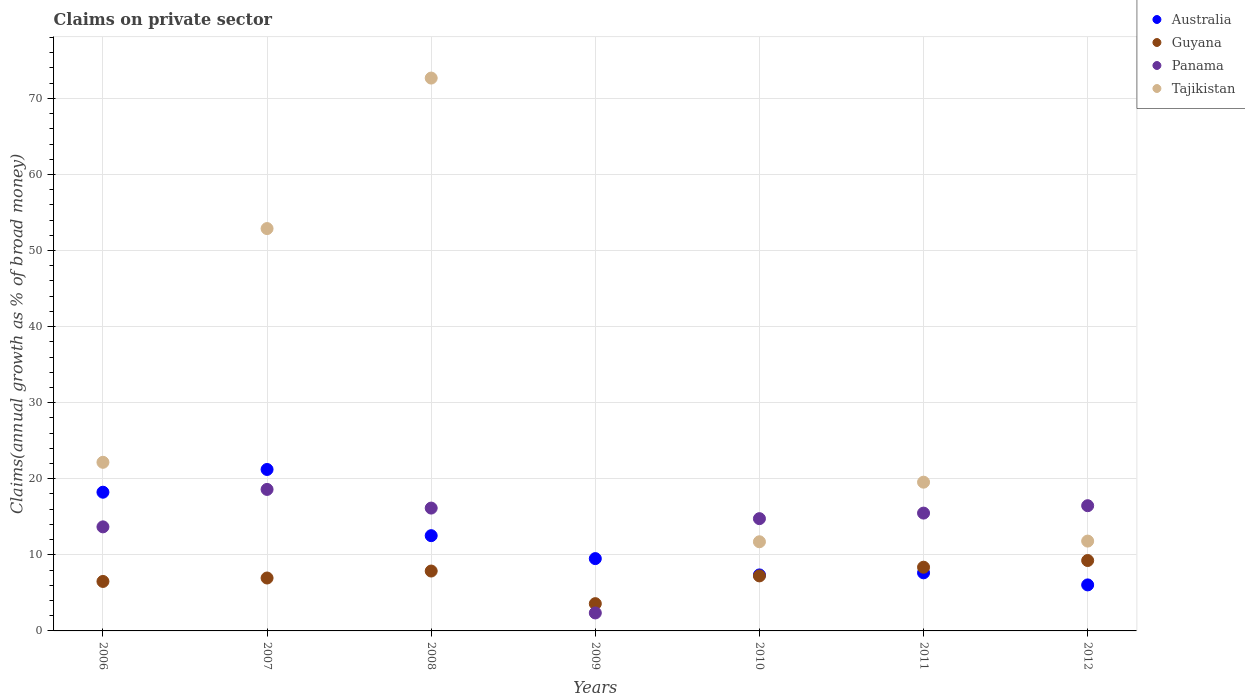How many different coloured dotlines are there?
Provide a short and direct response. 4. What is the percentage of broad money claimed on private sector in Australia in 2007?
Offer a very short reply. 21.22. Across all years, what is the maximum percentage of broad money claimed on private sector in Tajikistan?
Your answer should be very brief. 72.67. Across all years, what is the minimum percentage of broad money claimed on private sector in Panama?
Your answer should be compact. 2.36. In which year was the percentage of broad money claimed on private sector in Tajikistan maximum?
Your answer should be compact. 2008. What is the total percentage of broad money claimed on private sector in Australia in the graph?
Provide a short and direct response. 82.53. What is the difference between the percentage of broad money claimed on private sector in Australia in 2009 and that in 2012?
Keep it short and to the point. 3.46. What is the difference between the percentage of broad money claimed on private sector in Guyana in 2009 and the percentage of broad money claimed on private sector in Tajikistan in 2008?
Make the answer very short. -69.09. What is the average percentage of broad money claimed on private sector in Guyana per year?
Your response must be concise. 7.11. In the year 2006, what is the difference between the percentage of broad money claimed on private sector in Guyana and percentage of broad money claimed on private sector in Panama?
Make the answer very short. -7.17. What is the ratio of the percentage of broad money claimed on private sector in Guyana in 2006 to that in 2012?
Your answer should be very brief. 0.7. Is the percentage of broad money claimed on private sector in Panama in 2007 less than that in 2010?
Offer a very short reply. No. What is the difference between the highest and the second highest percentage of broad money claimed on private sector in Guyana?
Your answer should be very brief. 0.88. What is the difference between the highest and the lowest percentage of broad money claimed on private sector in Tajikistan?
Your response must be concise. 72.67. Is the sum of the percentage of broad money claimed on private sector in Australia in 2008 and 2011 greater than the maximum percentage of broad money claimed on private sector in Guyana across all years?
Make the answer very short. Yes. Is it the case that in every year, the sum of the percentage of broad money claimed on private sector in Panama and percentage of broad money claimed on private sector in Australia  is greater than the percentage of broad money claimed on private sector in Tajikistan?
Keep it short and to the point. No. Is the percentage of broad money claimed on private sector in Guyana strictly greater than the percentage of broad money claimed on private sector in Panama over the years?
Your answer should be compact. No. How many dotlines are there?
Your answer should be very brief. 4. How many years are there in the graph?
Provide a short and direct response. 7. What is the difference between two consecutive major ticks on the Y-axis?
Your response must be concise. 10. Are the values on the major ticks of Y-axis written in scientific E-notation?
Give a very brief answer. No. Does the graph contain any zero values?
Provide a short and direct response. Yes. Does the graph contain grids?
Provide a short and direct response. Yes. How are the legend labels stacked?
Provide a short and direct response. Vertical. What is the title of the graph?
Ensure brevity in your answer.  Claims on private sector. Does "American Samoa" appear as one of the legend labels in the graph?
Your answer should be very brief. No. What is the label or title of the Y-axis?
Offer a very short reply. Claims(annual growth as % of broad money). What is the Claims(annual growth as % of broad money) in Australia in 2006?
Make the answer very short. 18.23. What is the Claims(annual growth as % of broad money) in Guyana in 2006?
Your answer should be very brief. 6.5. What is the Claims(annual growth as % of broad money) of Panama in 2006?
Provide a succinct answer. 13.68. What is the Claims(annual growth as % of broad money) in Tajikistan in 2006?
Give a very brief answer. 22.17. What is the Claims(annual growth as % of broad money) in Australia in 2007?
Make the answer very short. 21.22. What is the Claims(annual growth as % of broad money) of Guyana in 2007?
Provide a short and direct response. 6.96. What is the Claims(annual growth as % of broad money) of Panama in 2007?
Make the answer very short. 18.6. What is the Claims(annual growth as % of broad money) of Tajikistan in 2007?
Your answer should be compact. 52.89. What is the Claims(annual growth as % of broad money) in Australia in 2008?
Your answer should be very brief. 12.52. What is the Claims(annual growth as % of broad money) of Guyana in 2008?
Your response must be concise. 7.87. What is the Claims(annual growth as % of broad money) of Panama in 2008?
Your answer should be compact. 16.15. What is the Claims(annual growth as % of broad money) of Tajikistan in 2008?
Your answer should be very brief. 72.67. What is the Claims(annual growth as % of broad money) of Australia in 2009?
Provide a succinct answer. 9.51. What is the Claims(annual growth as % of broad money) in Guyana in 2009?
Give a very brief answer. 3.58. What is the Claims(annual growth as % of broad money) of Panama in 2009?
Offer a terse response. 2.36. What is the Claims(annual growth as % of broad money) in Tajikistan in 2009?
Your answer should be compact. 0. What is the Claims(annual growth as % of broad money) of Australia in 2010?
Your response must be concise. 7.36. What is the Claims(annual growth as % of broad money) of Guyana in 2010?
Give a very brief answer. 7.23. What is the Claims(annual growth as % of broad money) of Panama in 2010?
Your response must be concise. 14.76. What is the Claims(annual growth as % of broad money) in Tajikistan in 2010?
Your answer should be very brief. 11.72. What is the Claims(annual growth as % of broad money) in Australia in 2011?
Your response must be concise. 7.64. What is the Claims(annual growth as % of broad money) in Guyana in 2011?
Provide a succinct answer. 8.37. What is the Claims(annual growth as % of broad money) of Panama in 2011?
Keep it short and to the point. 15.49. What is the Claims(annual growth as % of broad money) of Tajikistan in 2011?
Your response must be concise. 19.55. What is the Claims(annual growth as % of broad money) of Australia in 2012?
Your response must be concise. 6.05. What is the Claims(annual growth as % of broad money) in Guyana in 2012?
Give a very brief answer. 9.25. What is the Claims(annual growth as % of broad money) in Panama in 2012?
Your answer should be very brief. 16.46. What is the Claims(annual growth as % of broad money) in Tajikistan in 2012?
Offer a very short reply. 11.81. Across all years, what is the maximum Claims(annual growth as % of broad money) in Australia?
Provide a succinct answer. 21.22. Across all years, what is the maximum Claims(annual growth as % of broad money) of Guyana?
Offer a very short reply. 9.25. Across all years, what is the maximum Claims(annual growth as % of broad money) in Panama?
Provide a succinct answer. 18.6. Across all years, what is the maximum Claims(annual growth as % of broad money) of Tajikistan?
Your answer should be very brief. 72.67. Across all years, what is the minimum Claims(annual growth as % of broad money) in Australia?
Your answer should be very brief. 6.05. Across all years, what is the minimum Claims(annual growth as % of broad money) of Guyana?
Give a very brief answer. 3.58. Across all years, what is the minimum Claims(annual growth as % of broad money) in Panama?
Your response must be concise. 2.36. Across all years, what is the minimum Claims(annual growth as % of broad money) in Tajikistan?
Your answer should be compact. 0. What is the total Claims(annual growth as % of broad money) of Australia in the graph?
Offer a very short reply. 82.53. What is the total Claims(annual growth as % of broad money) in Guyana in the graph?
Offer a very short reply. 49.78. What is the total Claims(annual growth as % of broad money) in Panama in the graph?
Your answer should be very brief. 97.5. What is the total Claims(annual growth as % of broad money) of Tajikistan in the graph?
Ensure brevity in your answer.  190.81. What is the difference between the Claims(annual growth as % of broad money) in Australia in 2006 and that in 2007?
Make the answer very short. -2.99. What is the difference between the Claims(annual growth as % of broad money) of Guyana in 2006 and that in 2007?
Offer a very short reply. -0.45. What is the difference between the Claims(annual growth as % of broad money) in Panama in 2006 and that in 2007?
Make the answer very short. -4.92. What is the difference between the Claims(annual growth as % of broad money) in Tajikistan in 2006 and that in 2007?
Make the answer very short. -30.73. What is the difference between the Claims(annual growth as % of broad money) of Australia in 2006 and that in 2008?
Your response must be concise. 5.71. What is the difference between the Claims(annual growth as % of broad money) in Guyana in 2006 and that in 2008?
Your response must be concise. -1.37. What is the difference between the Claims(annual growth as % of broad money) in Panama in 2006 and that in 2008?
Give a very brief answer. -2.47. What is the difference between the Claims(annual growth as % of broad money) of Tajikistan in 2006 and that in 2008?
Ensure brevity in your answer.  -50.51. What is the difference between the Claims(annual growth as % of broad money) of Australia in 2006 and that in 2009?
Ensure brevity in your answer.  8.73. What is the difference between the Claims(annual growth as % of broad money) of Guyana in 2006 and that in 2009?
Give a very brief answer. 2.92. What is the difference between the Claims(annual growth as % of broad money) in Panama in 2006 and that in 2009?
Your answer should be very brief. 11.32. What is the difference between the Claims(annual growth as % of broad money) of Australia in 2006 and that in 2010?
Provide a succinct answer. 10.87. What is the difference between the Claims(annual growth as % of broad money) in Guyana in 2006 and that in 2010?
Ensure brevity in your answer.  -0.73. What is the difference between the Claims(annual growth as % of broad money) in Panama in 2006 and that in 2010?
Make the answer very short. -1.08. What is the difference between the Claims(annual growth as % of broad money) in Tajikistan in 2006 and that in 2010?
Offer a terse response. 10.45. What is the difference between the Claims(annual growth as % of broad money) of Australia in 2006 and that in 2011?
Provide a succinct answer. 10.6. What is the difference between the Claims(annual growth as % of broad money) of Guyana in 2006 and that in 2011?
Provide a succinct answer. -1.87. What is the difference between the Claims(annual growth as % of broad money) of Panama in 2006 and that in 2011?
Your answer should be compact. -1.81. What is the difference between the Claims(annual growth as % of broad money) of Tajikistan in 2006 and that in 2011?
Keep it short and to the point. 2.61. What is the difference between the Claims(annual growth as % of broad money) in Australia in 2006 and that in 2012?
Make the answer very short. 12.19. What is the difference between the Claims(annual growth as % of broad money) in Guyana in 2006 and that in 2012?
Ensure brevity in your answer.  -2.75. What is the difference between the Claims(annual growth as % of broad money) of Panama in 2006 and that in 2012?
Offer a very short reply. -2.78. What is the difference between the Claims(annual growth as % of broad money) in Tajikistan in 2006 and that in 2012?
Provide a short and direct response. 10.36. What is the difference between the Claims(annual growth as % of broad money) of Australia in 2007 and that in 2008?
Your answer should be compact. 8.7. What is the difference between the Claims(annual growth as % of broad money) of Guyana in 2007 and that in 2008?
Ensure brevity in your answer.  -0.92. What is the difference between the Claims(annual growth as % of broad money) of Panama in 2007 and that in 2008?
Give a very brief answer. 2.45. What is the difference between the Claims(annual growth as % of broad money) in Tajikistan in 2007 and that in 2008?
Keep it short and to the point. -19.78. What is the difference between the Claims(annual growth as % of broad money) of Australia in 2007 and that in 2009?
Your response must be concise. 11.72. What is the difference between the Claims(annual growth as % of broad money) of Guyana in 2007 and that in 2009?
Offer a very short reply. 3.37. What is the difference between the Claims(annual growth as % of broad money) of Panama in 2007 and that in 2009?
Make the answer very short. 16.24. What is the difference between the Claims(annual growth as % of broad money) of Australia in 2007 and that in 2010?
Your answer should be very brief. 13.86. What is the difference between the Claims(annual growth as % of broad money) in Guyana in 2007 and that in 2010?
Provide a succinct answer. -0.28. What is the difference between the Claims(annual growth as % of broad money) of Panama in 2007 and that in 2010?
Offer a terse response. 3.84. What is the difference between the Claims(annual growth as % of broad money) of Tajikistan in 2007 and that in 2010?
Make the answer very short. 41.17. What is the difference between the Claims(annual growth as % of broad money) of Australia in 2007 and that in 2011?
Offer a terse response. 13.59. What is the difference between the Claims(annual growth as % of broad money) of Guyana in 2007 and that in 2011?
Provide a short and direct response. -1.42. What is the difference between the Claims(annual growth as % of broad money) in Panama in 2007 and that in 2011?
Offer a terse response. 3.11. What is the difference between the Claims(annual growth as % of broad money) in Tajikistan in 2007 and that in 2011?
Offer a terse response. 33.34. What is the difference between the Claims(annual growth as % of broad money) in Australia in 2007 and that in 2012?
Ensure brevity in your answer.  15.17. What is the difference between the Claims(annual growth as % of broad money) of Guyana in 2007 and that in 2012?
Offer a terse response. -2.3. What is the difference between the Claims(annual growth as % of broad money) in Panama in 2007 and that in 2012?
Make the answer very short. 2.14. What is the difference between the Claims(annual growth as % of broad money) in Tajikistan in 2007 and that in 2012?
Provide a succinct answer. 41.08. What is the difference between the Claims(annual growth as % of broad money) in Australia in 2008 and that in 2009?
Make the answer very short. 3.01. What is the difference between the Claims(annual growth as % of broad money) in Guyana in 2008 and that in 2009?
Provide a short and direct response. 4.29. What is the difference between the Claims(annual growth as % of broad money) of Panama in 2008 and that in 2009?
Offer a very short reply. 13.78. What is the difference between the Claims(annual growth as % of broad money) of Australia in 2008 and that in 2010?
Provide a succinct answer. 5.16. What is the difference between the Claims(annual growth as % of broad money) of Guyana in 2008 and that in 2010?
Keep it short and to the point. 0.64. What is the difference between the Claims(annual growth as % of broad money) of Panama in 2008 and that in 2010?
Give a very brief answer. 1.39. What is the difference between the Claims(annual growth as % of broad money) of Tajikistan in 2008 and that in 2010?
Offer a terse response. 60.95. What is the difference between the Claims(annual growth as % of broad money) in Australia in 2008 and that in 2011?
Keep it short and to the point. 4.88. What is the difference between the Claims(annual growth as % of broad money) of Guyana in 2008 and that in 2011?
Provide a short and direct response. -0.5. What is the difference between the Claims(annual growth as % of broad money) in Panama in 2008 and that in 2011?
Your answer should be very brief. 0.66. What is the difference between the Claims(annual growth as % of broad money) of Tajikistan in 2008 and that in 2011?
Offer a very short reply. 53.12. What is the difference between the Claims(annual growth as % of broad money) of Australia in 2008 and that in 2012?
Give a very brief answer. 6.47. What is the difference between the Claims(annual growth as % of broad money) of Guyana in 2008 and that in 2012?
Keep it short and to the point. -1.38. What is the difference between the Claims(annual growth as % of broad money) of Panama in 2008 and that in 2012?
Make the answer very short. -0.31. What is the difference between the Claims(annual growth as % of broad money) in Tajikistan in 2008 and that in 2012?
Make the answer very short. 60.86. What is the difference between the Claims(annual growth as % of broad money) of Australia in 2009 and that in 2010?
Ensure brevity in your answer.  2.14. What is the difference between the Claims(annual growth as % of broad money) in Guyana in 2009 and that in 2010?
Your answer should be compact. -3.65. What is the difference between the Claims(annual growth as % of broad money) in Panama in 2009 and that in 2010?
Make the answer very short. -12.39. What is the difference between the Claims(annual growth as % of broad money) of Australia in 2009 and that in 2011?
Your answer should be very brief. 1.87. What is the difference between the Claims(annual growth as % of broad money) of Guyana in 2009 and that in 2011?
Your answer should be compact. -4.79. What is the difference between the Claims(annual growth as % of broad money) of Panama in 2009 and that in 2011?
Provide a succinct answer. -13.13. What is the difference between the Claims(annual growth as % of broad money) in Australia in 2009 and that in 2012?
Provide a short and direct response. 3.46. What is the difference between the Claims(annual growth as % of broad money) in Guyana in 2009 and that in 2012?
Keep it short and to the point. -5.67. What is the difference between the Claims(annual growth as % of broad money) in Panama in 2009 and that in 2012?
Offer a terse response. -14.1. What is the difference between the Claims(annual growth as % of broad money) in Australia in 2010 and that in 2011?
Your response must be concise. -0.27. What is the difference between the Claims(annual growth as % of broad money) in Guyana in 2010 and that in 2011?
Your response must be concise. -1.14. What is the difference between the Claims(annual growth as % of broad money) of Panama in 2010 and that in 2011?
Offer a very short reply. -0.73. What is the difference between the Claims(annual growth as % of broad money) of Tajikistan in 2010 and that in 2011?
Give a very brief answer. -7.83. What is the difference between the Claims(annual growth as % of broad money) in Australia in 2010 and that in 2012?
Keep it short and to the point. 1.31. What is the difference between the Claims(annual growth as % of broad money) of Guyana in 2010 and that in 2012?
Ensure brevity in your answer.  -2.02. What is the difference between the Claims(annual growth as % of broad money) in Panama in 2010 and that in 2012?
Ensure brevity in your answer.  -1.7. What is the difference between the Claims(annual growth as % of broad money) in Tajikistan in 2010 and that in 2012?
Ensure brevity in your answer.  -0.09. What is the difference between the Claims(annual growth as % of broad money) of Australia in 2011 and that in 2012?
Ensure brevity in your answer.  1.59. What is the difference between the Claims(annual growth as % of broad money) of Guyana in 2011 and that in 2012?
Ensure brevity in your answer.  -0.88. What is the difference between the Claims(annual growth as % of broad money) in Panama in 2011 and that in 2012?
Offer a terse response. -0.97. What is the difference between the Claims(annual growth as % of broad money) in Tajikistan in 2011 and that in 2012?
Your response must be concise. 7.74. What is the difference between the Claims(annual growth as % of broad money) in Australia in 2006 and the Claims(annual growth as % of broad money) in Guyana in 2007?
Offer a terse response. 11.28. What is the difference between the Claims(annual growth as % of broad money) of Australia in 2006 and the Claims(annual growth as % of broad money) of Panama in 2007?
Ensure brevity in your answer.  -0.37. What is the difference between the Claims(annual growth as % of broad money) of Australia in 2006 and the Claims(annual growth as % of broad money) of Tajikistan in 2007?
Ensure brevity in your answer.  -34.66. What is the difference between the Claims(annual growth as % of broad money) of Guyana in 2006 and the Claims(annual growth as % of broad money) of Panama in 2007?
Your answer should be very brief. -12.1. What is the difference between the Claims(annual growth as % of broad money) of Guyana in 2006 and the Claims(annual growth as % of broad money) of Tajikistan in 2007?
Your response must be concise. -46.39. What is the difference between the Claims(annual growth as % of broad money) in Panama in 2006 and the Claims(annual growth as % of broad money) in Tajikistan in 2007?
Make the answer very short. -39.21. What is the difference between the Claims(annual growth as % of broad money) of Australia in 2006 and the Claims(annual growth as % of broad money) of Guyana in 2008?
Keep it short and to the point. 10.36. What is the difference between the Claims(annual growth as % of broad money) in Australia in 2006 and the Claims(annual growth as % of broad money) in Panama in 2008?
Your response must be concise. 2.09. What is the difference between the Claims(annual growth as % of broad money) in Australia in 2006 and the Claims(annual growth as % of broad money) in Tajikistan in 2008?
Give a very brief answer. -54.44. What is the difference between the Claims(annual growth as % of broad money) of Guyana in 2006 and the Claims(annual growth as % of broad money) of Panama in 2008?
Provide a succinct answer. -9.64. What is the difference between the Claims(annual growth as % of broad money) of Guyana in 2006 and the Claims(annual growth as % of broad money) of Tajikistan in 2008?
Your response must be concise. -66.17. What is the difference between the Claims(annual growth as % of broad money) in Panama in 2006 and the Claims(annual growth as % of broad money) in Tajikistan in 2008?
Keep it short and to the point. -58.99. What is the difference between the Claims(annual growth as % of broad money) of Australia in 2006 and the Claims(annual growth as % of broad money) of Guyana in 2009?
Offer a terse response. 14.65. What is the difference between the Claims(annual growth as % of broad money) in Australia in 2006 and the Claims(annual growth as % of broad money) in Panama in 2009?
Your response must be concise. 15.87. What is the difference between the Claims(annual growth as % of broad money) of Guyana in 2006 and the Claims(annual growth as % of broad money) of Panama in 2009?
Give a very brief answer. 4.14. What is the difference between the Claims(annual growth as % of broad money) in Australia in 2006 and the Claims(annual growth as % of broad money) in Guyana in 2010?
Ensure brevity in your answer.  11. What is the difference between the Claims(annual growth as % of broad money) in Australia in 2006 and the Claims(annual growth as % of broad money) in Panama in 2010?
Give a very brief answer. 3.48. What is the difference between the Claims(annual growth as % of broad money) of Australia in 2006 and the Claims(annual growth as % of broad money) of Tajikistan in 2010?
Offer a terse response. 6.51. What is the difference between the Claims(annual growth as % of broad money) of Guyana in 2006 and the Claims(annual growth as % of broad money) of Panama in 2010?
Make the answer very short. -8.25. What is the difference between the Claims(annual growth as % of broad money) in Guyana in 2006 and the Claims(annual growth as % of broad money) in Tajikistan in 2010?
Offer a very short reply. -5.22. What is the difference between the Claims(annual growth as % of broad money) of Panama in 2006 and the Claims(annual growth as % of broad money) of Tajikistan in 2010?
Offer a terse response. 1.96. What is the difference between the Claims(annual growth as % of broad money) in Australia in 2006 and the Claims(annual growth as % of broad money) in Guyana in 2011?
Provide a short and direct response. 9.86. What is the difference between the Claims(annual growth as % of broad money) of Australia in 2006 and the Claims(annual growth as % of broad money) of Panama in 2011?
Provide a succinct answer. 2.75. What is the difference between the Claims(annual growth as % of broad money) of Australia in 2006 and the Claims(annual growth as % of broad money) of Tajikistan in 2011?
Provide a succinct answer. -1.32. What is the difference between the Claims(annual growth as % of broad money) of Guyana in 2006 and the Claims(annual growth as % of broad money) of Panama in 2011?
Provide a short and direct response. -8.98. What is the difference between the Claims(annual growth as % of broad money) of Guyana in 2006 and the Claims(annual growth as % of broad money) of Tajikistan in 2011?
Your answer should be compact. -13.05. What is the difference between the Claims(annual growth as % of broad money) of Panama in 2006 and the Claims(annual growth as % of broad money) of Tajikistan in 2011?
Offer a very short reply. -5.87. What is the difference between the Claims(annual growth as % of broad money) in Australia in 2006 and the Claims(annual growth as % of broad money) in Guyana in 2012?
Make the answer very short. 8.98. What is the difference between the Claims(annual growth as % of broad money) in Australia in 2006 and the Claims(annual growth as % of broad money) in Panama in 2012?
Provide a short and direct response. 1.77. What is the difference between the Claims(annual growth as % of broad money) of Australia in 2006 and the Claims(annual growth as % of broad money) of Tajikistan in 2012?
Your answer should be compact. 6.42. What is the difference between the Claims(annual growth as % of broad money) in Guyana in 2006 and the Claims(annual growth as % of broad money) in Panama in 2012?
Ensure brevity in your answer.  -9.96. What is the difference between the Claims(annual growth as % of broad money) in Guyana in 2006 and the Claims(annual growth as % of broad money) in Tajikistan in 2012?
Make the answer very short. -5.31. What is the difference between the Claims(annual growth as % of broad money) in Panama in 2006 and the Claims(annual growth as % of broad money) in Tajikistan in 2012?
Offer a very short reply. 1.87. What is the difference between the Claims(annual growth as % of broad money) of Australia in 2007 and the Claims(annual growth as % of broad money) of Guyana in 2008?
Your answer should be very brief. 13.35. What is the difference between the Claims(annual growth as % of broad money) in Australia in 2007 and the Claims(annual growth as % of broad money) in Panama in 2008?
Your answer should be very brief. 5.08. What is the difference between the Claims(annual growth as % of broad money) of Australia in 2007 and the Claims(annual growth as % of broad money) of Tajikistan in 2008?
Your answer should be very brief. -51.45. What is the difference between the Claims(annual growth as % of broad money) of Guyana in 2007 and the Claims(annual growth as % of broad money) of Panama in 2008?
Make the answer very short. -9.19. What is the difference between the Claims(annual growth as % of broad money) in Guyana in 2007 and the Claims(annual growth as % of broad money) in Tajikistan in 2008?
Keep it short and to the point. -65.72. What is the difference between the Claims(annual growth as % of broad money) in Panama in 2007 and the Claims(annual growth as % of broad money) in Tajikistan in 2008?
Offer a terse response. -54.07. What is the difference between the Claims(annual growth as % of broad money) in Australia in 2007 and the Claims(annual growth as % of broad money) in Guyana in 2009?
Your response must be concise. 17.64. What is the difference between the Claims(annual growth as % of broad money) in Australia in 2007 and the Claims(annual growth as % of broad money) in Panama in 2009?
Offer a terse response. 18.86. What is the difference between the Claims(annual growth as % of broad money) of Guyana in 2007 and the Claims(annual growth as % of broad money) of Panama in 2009?
Offer a terse response. 4.59. What is the difference between the Claims(annual growth as % of broad money) in Australia in 2007 and the Claims(annual growth as % of broad money) in Guyana in 2010?
Provide a short and direct response. 13.99. What is the difference between the Claims(annual growth as % of broad money) of Australia in 2007 and the Claims(annual growth as % of broad money) of Panama in 2010?
Your response must be concise. 6.47. What is the difference between the Claims(annual growth as % of broad money) in Australia in 2007 and the Claims(annual growth as % of broad money) in Tajikistan in 2010?
Make the answer very short. 9.5. What is the difference between the Claims(annual growth as % of broad money) of Guyana in 2007 and the Claims(annual growth as % of broad money) of Panama in 2010?
Provide a short and direct response. -7.8. What is the difference between the Claims(annual growth as % of broad money) in Guyana in 2007 and the Claims(annual growth as % of broad money) in Tajikistan in 2010?
Make the answer very short. -4.76. What is the difference between the Claims(annual growth as % of broad money) of Panama in 2007 and the Claims(annual growth as % of broad money) of Tajikistan in 2010?
Provide a short and direct response. 6.88. What is the difference between the Claims(annual growth as % of broad money) in Australia in 2007 and the Claims(annual growth as % of broad money) in Guyana in 2011?
Offer a terse response. 12.85. What is the difference between the Claims(annual growth as % of broad money) of Australia in 2007 and the Claims(annual growth as % of broad money) of Panama in 2011?
Provide a short and direct response. 5.73. What is the difference between the Claims(annual growth as % of broad money) of Australia in 2007 and the Claims(annual growth as % of broad money) of Tajikistan in 2011?
Make the answer very short. 1.67. What is the difference between the Claims(annual growth as % of broad money) in Guyana in 2007 and the Claims(annual growth as % of broad money) in Panama in 2011?
Your answer should be compact. -8.53. What is the difference between the Claims(annual growth as % of broad money) of Guyana in 2007 and the Claims(annual growth as % of broad money) of Tajikistan in 2011?
Give a very brief answer. -12.6. What is the difference between the Claims(annual growth as % of broad money) of Panama in 2007 and the Claims(annual growth as % of broad money) of Tajikistan in 2011?
Offer a very short reply. -0.95. What is the difference between the Claims(annual growth as % of broad money) of Australia in 2007 and the Claims(annual growth as % of broad money) of Guyana in 2012?
Offer a very short reply. 11.97. What is the difference between the Claims(annual growth as % of broad money) in Australia in 2007 and the Claims(annual growth as % of broad money) in Panama in 2012?
Your answer should be very brief. 4.76. What is the difference between the Claims(annual growth as % of broad money) in Australia in 2007 and the Claims(annual growth as % of broad money) in Tajikistan in 2012?
Keep it short and to the point. 9.41. What is the difference between the Claims(annual growth as % of broad money) in Guyana in 2007 and the Claims(annual growth as % of broad money) in Panama in 2012?
Keep it short and to the point. -9.51. What is the difference between the Claims(annual growth as % of broad money) of Guyana in 2007 and the Claims(annual growth as % of broad money) of Tajikistan in 2012?
Offer a terse response. -4.85. What is the difference between the Claims(annual growth as % of broad money) in Panama in 2007 and the Claims(annual growth as % of broad money) in Tajikistan in 2012?
Give a very brief answer. 6.79. What is the difference between the Claims(annual growth as % of broad money) of Australia in 2008 and the Claims(annual growth as % of broad money) of Guyana in 2009?
Your response must be concise. 8.94. What is the difference between the Claims(annual growth as % of broad money) of Australia in 2008 and the Claims(annual growth as % of broad money) of Panama in 2009?
Provide a succinct answer. 10.16. What is the difference between the Claims(annual growth as % of broad money) in Guyana in 2008 and the Claims(annual growth as % of broad money) in Panama in 2009?
Keep it short and to the point. 5.51. What is the difference between the Claims(annual growth as % of broad money) in Australia in 2008 and the Claims(annual growth as % of broad money) in Guyana in 2010?
Your answer should be compact. 5.29. What is the difference between the Claims(annual growth as % of broad money) of Australia in 2008 and the Claims(annual growth as % of broad money) of Panama in 2010?
Make the answer very short. -2.24. What is the difference between the Claims(annual growth as % of broad money) of Australia in 2008 and the Claims(annual growth as % of broad money) of Tajikistan in 2010?
Ensure brevity in your answer.  0.8. What is the difference between the Claims(annual growth as % of broad money) of Guyana in 2008 and the Claims(annual growth as % of broad money) of Panama in 2010?
Make the answer very short. -6.89. What is the difference between the Claims(annual growth as % of broad money) in Guyana in 2008 and the Claims(annual growth as % of broad money) in Tajikistan in 2010?
Give a very brief answer. -3.85. What is the difference between the Claims(annual growth as % of broad money) of Panama in 2008 and the Claims(annual growth as % of broad money) of Tajikistan in 2010?
Ensure brevity in your answer.  4.43. What is the difference between the Claims(annual growth as % of broad money) of Australia in 2008 and the Claims(annual growth as % of broad money) of Guyana in 2011?
Make the answer very short. 4.15. What is the difference between the Claims(annual growth as % of broad money) of Australia in 2008 and the Claims(annual growth as % of broad money) of Panama in 2011?
Offer a terse response. -2.97. What is the difference between the Claims(annual growth as % of broad money) in Australia in 2008 and the Claims(annual growth as % of broad money) in Tajikistan in 2011?
Your answer should be very brief. -7.03. What is the difference between the Claims(annual growth as % of broad money) of Guyana in 2008 and the Claims(annual growth as % of broad money) of Panama in 2011?
Keep it short and to the point. -7.62. What is the difference between the Claims(annual growth as % of broad money) of Guyana in 2008 and the Claims(annual growth as % of broad money) of Tajikistan in 2011?
Provide a short and direct response. -11.68. What is the difference between the Claims(annual growth as % of broad money) in Panama in 2008 and the Claims(annual growth as % of broad money) in Tajikistan in 2011?
Make the answer very short. -3.41. What is the difference between the Claims(annual growth as % of broad money) in Australia in 2008 and the Claims(annual growth as % of broad money) in Guyana in 2012?
Your response must be concise. 3.27. What is the difference between the Claims(annual growth as % of broad money) of Australia in 2008 and the Claims(annual growth as % of broad money) of Panama in 2012?
Your answer should be compact. -3.94. What is the difference between the Claims(annual growth as % of broad money) in Australia in 2008 and the Claims(annual growth as % of broad money) in Tajikistan in 2012?
Make the answer very short. 0.71. What is the difference between the Claims(annual growth as % of broad money) of Guyana in 2008 and the Claims(annual growth as % of broad money) of Panama in 2012?
Ensure brevity in your answer.  -8.59. What is the difference between the Claims(annual growth as % of broad money) in Guyana in 2008 and the Claims(annual growth as % of broad money) in Tajikistan in 2012?
Make the answer very short. -3.94. What is the difference between the Claims(annual growth as % of broad money) in Panama in 2008 and the Claims(annual growth as % of broad money) in Tajikistan in 2012?
Your answer should be compact. 4.34. What is the difference between the Claims(annual growth as % of broad money) of Australia in 2009 and the Claims(annual growth as % of broad money) of Guyana in 2010?
Give a very brief answer. 2.27. What is the difference between the Claims(annual growth as % of broad money) of Australia in 2009 and the Claims(annual growth as % of broad money) of Panama in 2010?
Keep it short and to the point. -5.25. What is the difference between the Claims(annual growth as % of broad money) of Australia in 2009 and the Claims(annual growth as % of broad money) of Tajikistan in 2010?
Your response must be concise. -2.21. What is the difference between the Claims(annual growth as % of broad money) in Guyana in 2009 and the Claims(annual growth as % of broad money) in Panama in 2010?
Offer a very short reply. -11.17. What is the difference between the Claims(annual growth as % of broad money) in Guyana in 2009 and the Claims(annual growth as % of broad money) in Tajikistan in 2010?
Keep it short and to the point. -8.14. What is the difference between the Claims(annual growth as % of broad money) of Panama in 2009 and the Claims(annual growth as % of broad money) of Tajikistan in 2010?
Ensure brevity in your answer.  -9.36. What is the difference between the Claims(annual growth as % of broad money) in Australia in 2009 and the Claims(annual growth as % of broad money) in Guyana in 2011?
Keep it short and to the point. 1.13. What is the difference between the Claims(annual growth as % of broad money) of Australia in 2009 and the Claims(annual growth as % of broad money) of Panama in 2011?
Ensure brevity in your answer.  -5.98. What is the difference between the Claims(annual growth as % of broad money) of Australia in 2009 and the Claims(annual growth as % of broad money) of Tajikistan in 2011?
Give a very brief answer. -10.05. What is the difference between the Claims(annual growth as % of broad money) of Guyana in 2009 and the Claims(annual growth as % of broad money) of Panama in 2011?
Your response must be concise. -11.9. What is the difference between the Claims(annual growth as % of broad money) of Guyana in 2009 and the Claims(annual growth as % of broad money) of Tajikistan in 2011?
Your response must be concise. -15.97. What is the difference between the Claims(annual growth as % of broad money) in Panama in 2009 and the Claims(annual growth as % of broad money) in Tajikistan in 2011?
Your answer should be compact. -17.19. What is the difference between the Claims(annual growth as % of broad money) in Australia in 2009 and the Claims(annual growth as % of broad money) in Guyana in 2012?
Provide a short and direct response. 0.25. What is the difference between the Claims(annual growth as % of broad money) in Australia in 2009 and the Claims(annual growth as % of broad money) in Panama in 2012?
Ensure brevity in your answer.  -6.95. What is the difference between the Claims(annual growth as % of broad money) in Australia in 2009 and the Claims(annual growth as % of broad money) in Tajikistan in 2012?
Ensure brevity in your answer.  -2.3. What is the difference between the Claims(annual growth as % of broad money) of Guyana in 2009 and the Claims(annual growth as % of broad money) of Panama in 2012?
Make the answer very short. -12.88. What is the difference between the Claims(annual growth as % of broad money) of Guyana in 2009 and the Claims(annual growth as % of broad money) of Tajikistan in 2012?
Ensure brevity in your answer.  -8.23. What is the difference between the Claims(annual growth as % of broad money) of Panama in 2009 and the Claims(annual growth as % of broad money) of Tajikistan in 2012?
Offer a terse response. -9.45. What is the difference between the Claims(annual growth as % of broad money) in Australia in 2010 and the Claims(annual growth as % of broad money) in Guyana in 2011?
Ensure brevity in your answer.  -1.01. What is the difference between the Claims(annual growth as % of broad money) in Australia in 2010 and the Claims(annual growth as % of broad money) in Panama in 2011?
Your answer should be compact. -8.13. What is the difference between the Claims(annual growth as % of broad money) of Australia in 2010 and the Claims(annual growth as % of broad money) of Tajikistan in 2011?
Provide a succinct answer. -12.19. What is the difference between the Claims(annual growth as % of broad money) in Guyana in 2010 and the Claims(annual growth as % of broad money) in Panama in 2011?
Ensure brevity in your answer.  -8.26. What is the difference between the Claims(annual growth as % of broad money) in Guyana in 2010 and the Claims(annual growth as % of broad money) in Tajikistan in 2011?
Provide a succinct answer. -12.32. What is the difference between the Claims(annual growth as % of broad money) in Panama in 2010 and the Claims(annual growth as % of broad money) in Tajikistan in 2011?
Your answer should be very brief. -4.8. What is the difference between the Claims(annual growth as % of broad money) of Australia in 2010 and the Claims(annual growth as % of broad money) of Guyana in 2012?
Your answer should be very brief. -1.89. What is the difference between the Claims(annual growth as % of broad money) in Australia in 2010 and the Claims(annual growth as % of broad money) in Panama in 2012?
Give a very brief answer. -9.1. What is the difference between the Claims(annual growth as % of broad money) of Australia in 2010 and the Claims(annual growth as % of broad money) of Tajikistan in 2012?
Give a very brief answer. -4.45. What is the difference between the Claims(annual growth as % of broad money) of Guyana in 2010 and the Claims(annual growth as % of broad money) of Panama in 2012?
Ensure brevity in your answer.  -9.23. What is the difference between the Claims(annual growth as % of broad money) of Guyana in 2010 and the Claims(annual growth as % of broad money) of Tajikistan in 2012?
Make the answer very short. -4.58. What is the difference between the Claims(annual growth as % of broad money) in Panama in 2010 and the Claims(annual growth as % of broad money) in Tajikistan in 2012?
Provide a succinct answer. 2.95. What is the difference between the Claims(annual growth as % of broad money) in Australia in 2011 and the Claims(annual growth as % of broad money) in Guyana in 2012?
Your answer should be compact. -1.62. What is the difference between the Claims(annual growth as % of broad money) in Australia in 2011 and the Claims(annual growth as % of broad money) in Panama in 2012?
Keep it short and to the point. -8.82. What is the difference between the Claims(annual growth as % of broad money) in Australia in 2011 and the Claims(annual growth as % of broad money) in Tajikistan in 2012?
Ensure brevity in your answer.  -4.17. What is the difference between the Claims(annual growth as % of broad money) in Guyana in 2011 and the Claims(annual growth as % of broad money) in Panama in 2012?
Offer a very short reply. -8.09. What is the difference between the Claims(annual growth as % of broad money) of Guyana in 2011 and the Claims(annual growth as % of broad money) of Tajikistan in 2012?
Your answer should be compact. -3.43. What is the difference between the Claims(annual growth as % of broad money) of Panama in 2011 and the Claims(annual growth as % of broad money) of Tajikistan in 2012?
Offer a terse response. 3.68. What is the average Claims(annual growth as % of broad money) of Australia per year?
Keep it short and to the point. 11.79. What is the average Claims(annual growth as % of broad money) of Guyana per year?
Provide a succinct answer. 7.11. What is the average Claims(annual growth as % of broad money) of Panama per year?
Your response must be concise. 13.93. What is the average Claims(annual growth as % of broad money) of Tajikistan per year?
Offer a terse response. 27.26. In the year 2006, what is the difference between the Claims(annual growth as % of broad money) in Australia and Claims(annual growth as % of broad money) in Guyana?
Your answer should be very brief. 11.73. In the year 2006, what is the difference between the Claims(annual growth as % of broad money) of Australia and Claims(annual growth as % of broad money) of Panama?
Your answer should be very brief. 4.56. In the year 2006, what is the difference between the Claims(annual growth as % of broad money) of Australia and Claims(annual growth as % of broad money) of Tajikistan?
Your answer should be compact. -3.93. In the year 2006, what is the difference between the Claims(annual growth as % of broad money) in Guyana and Claims(annual growth as % of broad money) in Panama?
Make the answer very short. -7.17. In the year 2006, what is the difference between the Claims(annual growth as % of broad money) of Guyana and Claims(annual growth as % of broad money) of Tajikistan?
Your answer should be compact. -15.66. In the year 2006, what is the difference between the Claims(annual growth as % of broad money) in Panama and Claims(annual growth as % of broad money) in Tajikistan?
Your response must be concise. -8.49. In the year 2007, what is the difference between the Claims(annual growth as % of broad money) of Australia and Claims(annual growth as % of broad money) of Guyana?
Offer a very short reply. 14.27. In the year 2007, what is the difference between the Claims(annual growth as % of broad money) of Australia and Claims(annual growth as % of broad money) of Panama?
Give a very brief answer. 2.62. In the year 2007, what is the difference between the Claims(annual growth as % of broad money) in Australia and Claims(annual growth as % of broad money) in Tajikistan?
Keep it short and to the point. -31.67. In the year 2007, what is the difference between the Claims(annual growth as % of broad money) of Guyana and Claims(annual growth as % of broad money) of Panama?
Your response must be concise. -11.65. In the year 2007, what is the difference between the Claims(annual growth as % of broad money) of Guyana and Claims(annual growth as % of broad money) of Tajikistan?
Your response must be concise. -45.94. In the year 2007, what is the difference between the Claims(annual growth as % of broad money) of Panama and Claims(annual growth as % of broad money) of Tajikistan?
Provide a succinct answer. -34.29. In the year 2008, what is the difference between the Claims(annual growth as % of broad money) in Australia and Claims(annual growth as % of broad money) in Guyana?
Make the answer very short. 4.65. In the year 2008, what is the difference between the Claims(annual growth as % of broad money) of Australia and Claims(annual growth as % of broad money) of Panama?
Your answer should be very brief. -3.63. In the year 2008, what is the difference between the Claims(annual growth as % of broad money) in Australia and Claims(annual growth as % of broad money) in Tajikistan?
Provide a succinct answer. -60.15. In the year 2008, what is the difference between the Claims(annual growth as % of broad money) of Guyana and Claims(annual growth as % of broad money) of Panama?
Give a very brief answer. -8.28. In the year 2008, what is the difference between the Claims(annual growth as % of broad money) in Guyana and Claims(annual growth as % of broad money) in Tajikistan?
Provide a short and direct response. -64.8. In the year 2008, what is the difference between the Claims(annual growth as % of broad money) of Panama and Claims(annual growth as % of broad money) of Tajikistan?
Offer a terse response. -56.53. In the year 2009, what is the difference between the Claims(annual growth as % of broad money) in Australia and Claims(annual growth as % of broad money) in Guyana?
Your answer should be compact. 5.92. In the year 2009, what is the difference between the Claims(annual growth as % of broad money) of Australia and Claims(annual growth as % of broad money) of Panama?
Provide a short and direct response. 7.14. In the year 2009, what is the difference between the Claims(annual growth as % of broad money) in Guyana and Claims(annual growth as % of broad money) in Panama?
Make the answer very short. 1.22. In the year 2010, what is the difference between the Claims(annual growth as % of broad money) in Australia and Claims(annual growth as % of broad money) in Guyana?
Offer a very short reply. 0.13. In the year 2010, what is the difference between the Claims(annual growth as % of broad money) of Australia and Claims(annual growth as % of broad money) of Panama?
Keep it short and to the point. -7.39. In the year 2010, what is the difference between the Claims(annual growth as % of broad money) of Australia and Claims(annual growth as % of broad money) of Tajikistan?
Give a very brief answer. -4.36. In the year 2010, what is the difference between the Claims(annual growth as % of broad money) in Guyana and Claims(annual growth as % of broad money) in Panama?
Offer a very short reply. -7.53. In the year 2010, what is the difference between the Claims(annual growth as % of broad money) of Guyana and Claims(annual growth as % of broad money) of Tajikistan?
Give a very brief answer. -4.49. In the year 2010, what is the difference between the Claims(annual growth as % of broad money) in Panama and Claims(annual growth as % of broad money) in Tajikistan?
Offer a very short reply. 3.04. In the year 2011, what is the difference between the Claims(annual growth as % of broad money) in Australia and Claims(annual growth as % of broad money) in Guyana?
Provide a short and direct response. -0.74. In the year 2011, what is the difference between the Claims(annual growth as % of broad money) in Australia and Claims(annual growth as % of broad money) in Panama?
Provide a succinct answer. -7.85. In the year 2011, what is the difference between the Claims(annual growth as % of broad money) of Australia and Claims(annual growth as % of broad money) of Tajikistan?
Your answer should be compact. -11.92. In the year 2011, what is the difference between the Claims(annual growth as % of broad money) of Guyana and Claims(annual growth as % of broad money) of Panama?
Ensure brevity in your answer.  -7.11. In the year 2011, what is the difference between the Claims(annual growth as % of broad money) in Guyana and Claims(annual growth as % of broad money) in Tajikistan?
Provide a short and direct response. -11.18. In the year 2011, what is the difference between the Claims(annual growth as % of broad money) in Panama and Claims(annual growth as % of broad money) in Tajikistan?
Ensure brevity in your answer.  -4.06. In the year 2012, what is the difference between the Claims(annual growth as % of broad money) of Australia and Claims(annual growth as % of broad money) of Guyana?
Offer a terse response. -3.21. In the year 2012, what is the difference between the Claims(annual growth as % of broad money) in Australia and Claims(annual growth as % of broad money) in Panama?
Offer a terse response. -10.41. In the year 2012, what is the difference between the Claims(annual growth as % of broad money) of Australia and Claims(annual growth as % of broad money) of Tajikistan?
Your answer should be very brief. -5.76. In the year 2012, what is the difference between the Claims(annual growth as % of broad money) of Guyana and Claims(annual growth as % of broad money) of Panama?
Offer a terse response. -7.21. In the year 2012, what is the difference between the Claims(annual growth as % of broad money) in Guyana and Claims(annual growth as % of broad money) in Tajikistan?
Your answer should be compact. -2.55. In the year 2012, what is the difference between the Claims(annual growth as % of broad money) in Panama and Claims(annual growth as % of broad money) in Tajikistan?
Offer a terse response. 4.65. What is the ratio of the Claims(annual growth as % of broad money) of Australia in 2006 to that in 2007?
Your answer should be very brief. 0.86. What is the ratio of the Claims(annual growth as % of broad money) of Guyana in 2006 to that in 2007?
Give a very brief answer. 0.94. What is the ratio of the Claims(annual growth as % of broad money) in Panama in 2006 to that in 2007?
Ensure brevity in your answer.  0.74. What is the ratio of the Claims(annual growth as % of broad money) of Tajikistan in 2006 to that in 2007?
Provide a succinct answer. 0.42. What is the ratio of the Claims(annual growth as % of broad money) of Australia in 2006 to that in 2008?
Make the answer very short. 1.46. What is the ratio of the Claims(annual growth as % of broad money) of Guyana in 2006 to that in 2008?
Your answer should be very brief. 0.83. What is the ratio of the Claims(annual growth as % of broad money) of Panama in 2006 to that in 2008?
Offer a terse response. 0.85. What is the ratio of the Claims(annual growth as % of broad money) of Tajikistan in 2006 to that in 2008?
Provide a succinct answer. 0.3. What is the ratio of the Claims(annual growth as % of broad money) in Australia in 2006 to that in 2009?
Your answer should be very brief. 1.92. What is the ratio of the Claims(annual growth as % of broad money) of Guyana in 2006 to that in 2009?
Ensure brevity in your answer.  1.81. What is the ratio of the Claims(annual growth as % of broad money) of Panama in 2006 to that in 2009?
Keep it short and to the point. 5.79. What is the ratio of the Claims(annual growth as % of broad money) in Australia in 2006 to that in 2010?
Make the answer very short. 2.48. What is the ratio of the Claims(annual growth as % of broad money) of Guyana in 2006 to that in 2010?
Give a very brief answer. 0.9. What is the ratio of the Claims(annual growth as % of broad money) in Panama in 2006 to that in 2010?
Your response must be concise. 0.93. What is the ratio of the Claims(annual growth as % of broad money) of Tajikistan in 2006 to that in 2010?
Provide a succinct answer. 1.89. What is the ratio of the Claims(annual growth as % of broad money) of Australia in 2006 to that in 2011?
Your response must be concise. 2.39. What is the ratio of the Claims(annual growth as % of broad money) of Guyana in 2006 to that in 2011?
Your response must be concise. 0.78. What is the ratio of the Claims(annual growth as % of broad money) in Panama in 2006 to that in 2011?
Provide a succinct answer. 0.88. What is the ratio of the Claims(annual growth as % of broad money) in Tajikistan in 2006 to that in 2011?
Offer a terse response. 1.13. What is the ratio of the Claims(annual growth as % of broad money) in Australia in 2006 to that in 2012?
Provide a short and direct response. 3.01. What is the ratio of the Claims(annual growth as % of broad money) of Guyana in 2006 to that in 2012?
Make the answer very short. 0.7. What is the ratio of the Claims(annual growth as % of broad money) of Panama in 2006 to that in 2012?
Give a very brief answer. 0.83. What is the ratio of the Claims(annual growth as % of broad money) in Tajikistan in 2006 to that in 2012?
Give a very brief answer. 1.88. What is the ratio of the Claims(annual growth as % of broad money) of Australia in 2007 to that in 2008?
Your answer should be compact. 1.7. What is the ratio of the Claims(annual growth as % of broad money) of Guyana in 2007 to that in 2008?
Your answer should be compact. 0.88. What is the ratio of the Claims(annual growth as % of broad money) of Panama in 2007 to that in 2008?
Make the answer very short. 1.15. What is the ratio of the Claims(annual growth as % of broad money) in Tajikistan in 2007 to that in 2008?
Your answer should be very brief. 0.73. What is the ratio of the Claims(annual growth as % of broad money) of Australia in 2007 to that in 2009?
Your answer should be compact. 2.23. What is the ratio of the Claims(annual growth as % of broad money) in Guyana in 2007 to that in 2009?
Your answer should be compact. 1.94. What is the ratio of the Claims(annual growth as % of broad money) in Panama in 2007 to that in 2009?
Keep it short and to the point. 7.87. What is the ratio of the Claims(annual growth as % of broad money) in Australia in 2007 to that in 2010?
Provide a short and direct response. 2.88. What is the ratio of the Claims(annual growth as % of broad money) in Guyana in 2007 to that in 2010?
Your answer should be very brief. 0.96. What is the ratio of the Claims(annual growth as % of broad money) in Panama in 2007 to that in 2010?
Your answer should be very brief. 1.26. What is the ratio of the Claims(annual growth as % of broad money) in Tajikistan in 2007 to that in 2010?
Your answer should be compact. 4.51. What is the ratio of the Claims(annual growth as % of broad money) in Australia in 2007 to that in 2011?
Give a very brief answer. 2.78. What is the ratio of the Claims(annual growth as % of broad money) in Guyana in 2007 to that in 2011?
Ensure brevity in your answer.  0.83. What is the ratio of the Claims(annual growth as % of broad money) of Panama in 2007 to that in 2011?
Provide a succinct answer. 1.2. What is the ratio of the Claims(annual growth as % of broad money) in Tajikistan in 2007 to that in 2011?
Keep it short and to the point. 2.7. What is the ratio of the Claims(annual growth as % of broad money) of Australia in 2007 to that in 2012?
Ensure brevity in your answer.  3.51. What is the ratio of the Claims(annual growth as % of broad money) in Guyana in 2007 to that in 2012?
Keep it short and to the point. 0.75. What is the ratio of the Claims(annual growth as % of broad money) in Panama in 2007 to that in 2012?
Your answer should be compact. 1.13. What is the ratio of the Claims(annual growth as % of broad money) of Tajikistan in 2007 to that in 2012?
Give a very brief answer. 4.48. What is the ratio of the Claims(annual growth as % of broad money) in Australia in 2008 to that in 2009?
Your answer should be very brief. 1.32. What is the ratio of the Claims(annual growth as % of broad money) in Guyana in 2008 to that in 2009?
Offer a very short reply. 2.2. What is the ratio of the Claims(annual growth as % of broad money) in Panama in 2008 to that in 2009?
Give a very brief answer. 6.83. What is the ratio of the Claims(annual growth as % of broad money) in Australia in 2008 to that in 2010?
Your answer should be very brief. 1.7. What is the ratio of the Claims(annual growth as % of broad money) in Guyana in 2008 to that in 2010?
Your response must be concise. 1.09. What is the ratio of the Claims(annual growth as % of broad money) in Panama in 2008 to that in 2010?
Provide a short and direct response. 1.09. What is the ratio of the Claims(annual growth as % of broad money) in Tajikistan in 2008 to that in 2010?
Your answer should be very brief. 6.2. What is the ratio of the Claims(annual growth as % of broad money) of Australia in 2008 to that in 2011?
Provide a succinct answer. 1.64. What is the ratio of the Claims(annual growth as % of broad money) in Panama in 2008 to that in 2011?
Make the answer very short. 1.04. What is the ratio of the Claims(annual growth as % of broad money) of Tajikistan in 2008 to that in 2011?
Your answer should be compact. 3.72. What is the ratio of the Claims(annual growth as % of broad money) in Australia in 2008 to that in 2012?
Your answer should be compact. 2.07. What is the ratio of the Claims(annual growth as % of broad money) in Guyana in 2008 to that in 2012?
Your answer should be very brief. 0.85. What is the ratio of the Claims(annual growth as % of broad money) in Panama in 2008 to that in 2012?
Ensure brevity in your answer.  0.98. What is the ratio of the Claims(annual growth as % of broad money) of Tajikistan in 2008 to that in 2012?
Ensure brevity in your answer.  6.15. What is the ratio of the Claims(annual growth as % of broad money) of Australia in 2009 to that in 2010?
Ensure brevity in your answer.  1.29. What is the ratio of the Claims(annual growth as % of broad money) of Guyana in 2009 to that in 2010?
Offer a very short reply. 0.5. What is the ratio of the Claims(annual growth as % of broad money) in Panama in 2009 to that in 2010?
Your answer should be compact. 0.16. What is the ratio of the Claims(annual growth as % of broad money) of Australia in 2009 to that in 2011?
Your answer should be compact. 1.24. What is the ratio of the Claims(annual growth as % of broad money) in Guyana in 2009 to that in 2011?
Ensure brevity in your answer.  0.43. What is the ratio of the Claims(annual growth as % of broad money) in Panama in 2009 to that in 2011?
Your response must be concise. 0.15. What is the ratio of the Claims(annual growth as % of broad money) in Australia in 2009 to that in 2012?
Provide a succinct answer. 1.57. What is the ratio of the Claims(annual growth as % of broad money) in Guyana in 2009 to that in 2012?
Provide a succinct answer. 0.39. What is the ratio of the Claims(annual growth as % of broad money) in Panama in 2009 to that in 2012?
Your response must be concise. 0.14. What is the ratio of the Claims(annual growth as % of broad money) of Australia in 2010 to that in 2011?
Make the answer very short. 0.96. What is the ratio of the Claims(annual growth as % of broad money) of Guyana in 2010 to that in 2011?
Your response must be concise. 0.86. What is the ratio of the Claims(annual growth as % of broad money) of Panama in 2010 to that in 2011?
Make the answer very short. 0.95. What is the ratio of the Claims(annual growth as % of broad money) in Tajikistan in 2010 to that in 2011?
Make the answer very short. 0.6. What is the ratio of the Claims(annual growth as % of broad money) of Australia in 2010 to that in 2012?
Keep it short and to the point. 1.22. What is the ratio of the Claims(annual growth as % of broad money) in Guyana in 2010 to that in 2012?
Your answer should be very brief. 0.78. What is the ratio of the Claims(annual growth as % of broad money) of Panama in 2010 to that in 2012?
Offer a very short reply. 0.9. What is the ratio of the Claims(annual growth as % of broad money) of Tajikistan in 2010 to that in 2012?
Your response must be concise. 0.99. What is the ratio of the Claims(annual growth as % of broad money) in Australia in 2011 to that in 2012?
Your answer should be compact. 1.26. What is the ratio of the Claims(annual growth as % of broad money) in Guyana in 2011 to that in 2012?
Offer a very short reply. 0.9. What is the ratio of the Claims(annual growth as % of broad money) in Panama in 2011 to that in 2012?
Keep it short and to the point. 0.94. What is the ratio of the Claims(annual growth as % of broad money) in Tajikistan in 2011 to that in 2012?
Give a very brief answer. 1.66. What is the difference between the highest and the second highest Claims(annual growth as % of broad money) of Australia?
Offer a very short reply. 2.99. What is the difference between the highest and the second highest Claims(annual growth as % of broad money) of Guyana?
Keep it short and to the point. 0.88. What is the difference between the highest and the second highest Claims(annual growth as % of broad money) of Panama?
Offer a very short reply. 2.14. What is the difference between the highest and the second highest Claims(annual growth as % of broad money) of Tajikistan?
Keep it short and to the point. 19.78. What is the difference between the highest and the lowest Claims(annual growth as % of broad money) of Australia?
Offer a very short reply. 15.17. What is the difference between the highest and the lowest Claims(annual growth as % of broad money) in Guyana?
Make the answer very short. 5.67. What is the difference between the highest and the lowest Claims(annual growth as % of broad money) of Panama?
Offer a terse response. 16.24. What is the difference between the highest and the lowest Claims(annual growth as % of broad money) of Tajikistan?
Your response must be concise. 72.67. 